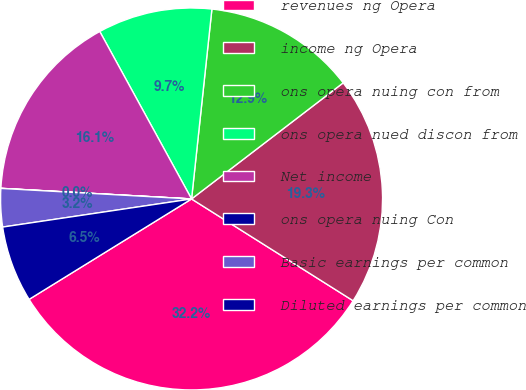Convert chart. <chart><loc_0><loc_0><loc_500><loc_500><pie_chart><fcel>revenues ng Opera<fcel>income ng Opera<fcel>ons opera nuing con from<fcel>ons opera nued discon from<fcel>Net income<fcel>ons opera nuing Con<fcel>Basic earnings per common<fcel>Diluted earnings per common<nl><fcel>32.24%<fcel>19.35%<fcel>12.9%<fcel>9.68%<fcel>16.13%<fcel>0.01%<fcel>3.23%<fcel>6.46%<nl></chart> 